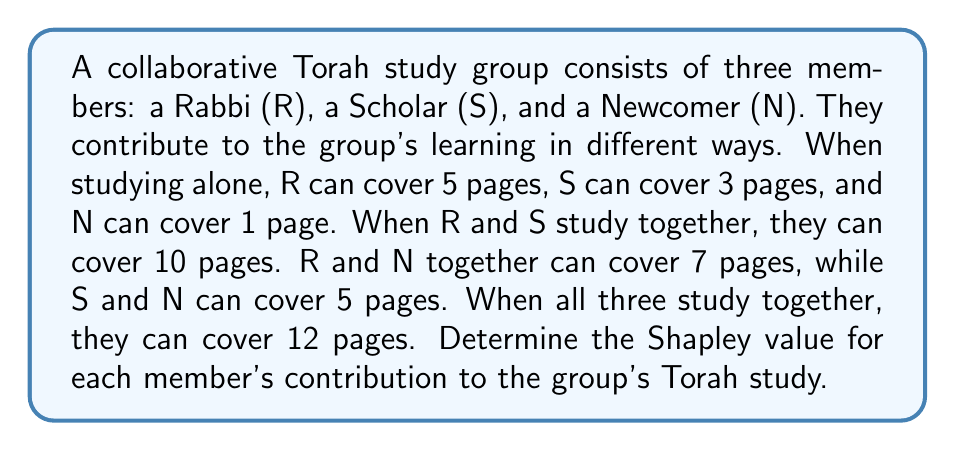Show me your answer to this math problem. To determine the Shapley value, we need to calculate the marginal contribution of each player in all possible coalitions and then take the average. Let's follow these steps:

1) First, list all possible coalitions and their values:
   $v(\{\}) = 0$
   $v(\{R\}) = 5$
   $v(\{S\}) = 3$
   $v(\{N\}) = 1$
   $v(\{R,S\}) = 10$
   $v(\{R,N\}) = 7$
   $v(\{S,N\}) = 5$
   $v(\{R,S,N\}) = 12$

2) Calculate marginal contributions for each player in all orderings:

   R,S,N: R:5, S:5, N:2
   R,N,S: R:5, N:2, S:5
   S,R,N: S:3, R:7, N:2
   S,N,R: S:3, N:2, R:7
   N,R,S: N:1, R:6, S:5
   N,S,R: N:1, S:4, R:7

3) The Shapley value is the average of these marginal contributions. There are 6 orderings, so we divide the sum by 6:

   For R: $\phi_R = \frac{5+5+7+7+6+7}{6} = \frac{37}{6}$

   For S: $\phi_S = \frac{5+5+3+3+5+4}{6} = \frac{25}{6}$

   For N: $\phi_N = \frac{2+2+2+2+1+1}{6} = \frac{10}{6} = \frac{5}{3}$

4) We can verify that the sum of Shapley values equals the value of the grand coalition:

   $\frac{37}{6} + \frac{25}{6} + \frac{10}{6} = \frac{72}{6} = 12 = v(\{R,S,N\})$

The Shapley value represents each player's fair share based on their average marginal contribution, reflecting the Jewish value of recognizing each individual's unique contribution to communal learning.
Answer: The Shapley values for the collaborative Torah study group are:

Rabbi (R): $\frac{37}{6} \approx 6.17$ pages
Scholar (S): $\frac{25}{6} \approx 4.17$ pages
Newcomer (N): $\frac{5}{3} \approx 1.67$ pages 